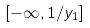<formula> <loc_0><loc_0><loc_500><loc_500>[ - \infty , 1 / y _ { 1 } ]</formula> 